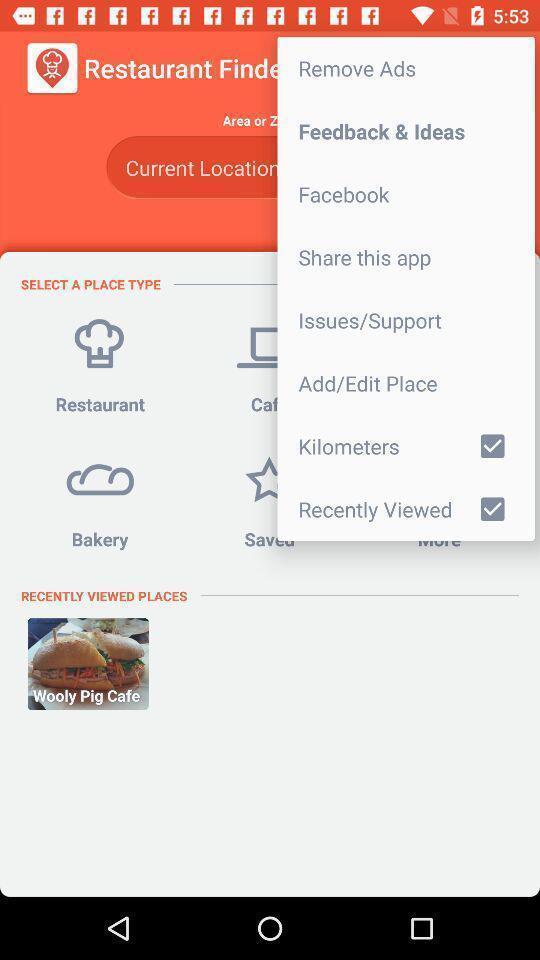Summarize the main components in this picture. Window displaying an food app. 